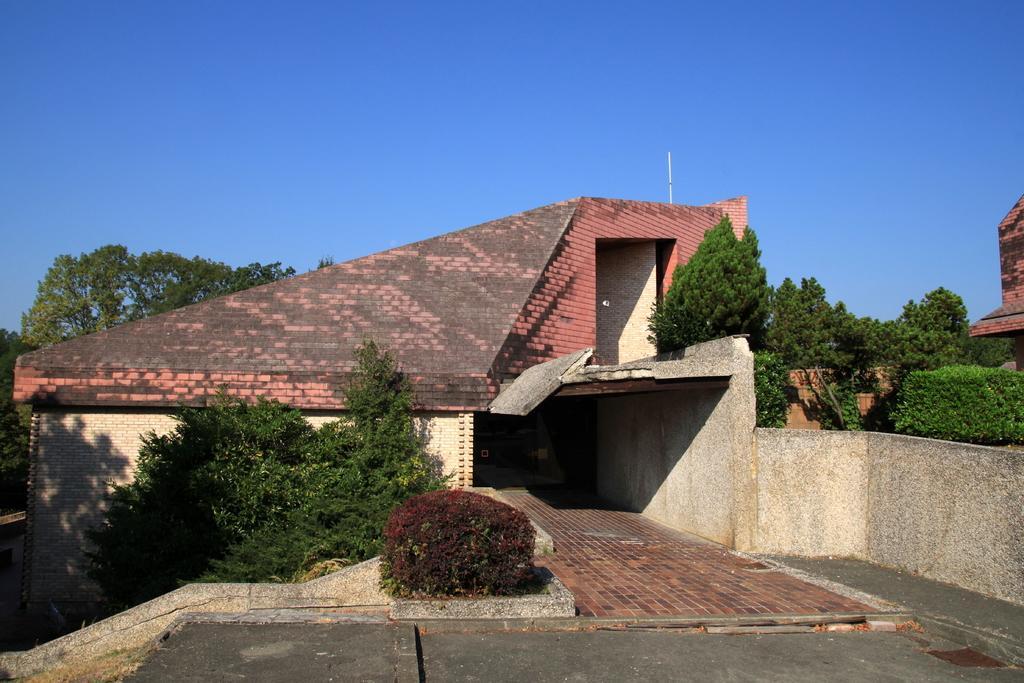Could you give a brief overview of what you see in this image? In this picture we can see a house and in front of the house there are plants and a path. Behind the house there are trees and a sky. 